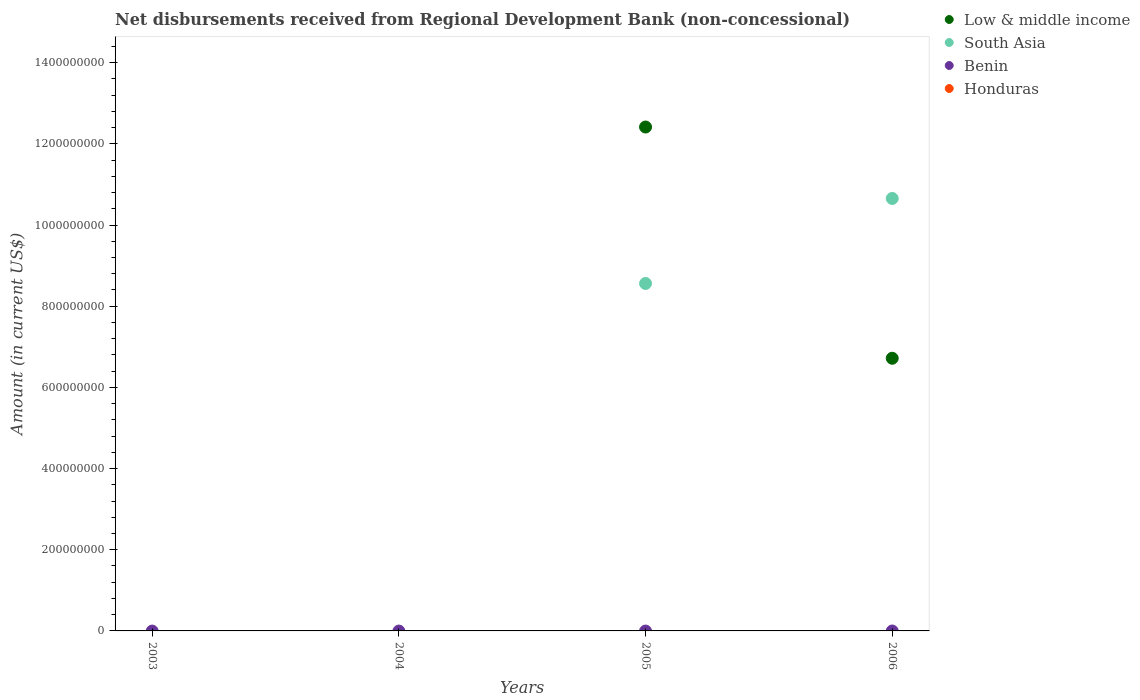What is the amount of disbursements received from Regional Development Bank in Benin in 2005?
Ensure brevity in your answer.  0. Across all years, what is the maximum amount of disbursements received from Regional Development Bank in Low & middle income?
Your answer should be compact. 1.24e+09. Across all years, what is the minimum amount of disbursements received from Regional Development Bank in Low & middle income?
Provide a succinct answer. 0. What is the total amount of disbursements received from Regional Development Bank in Benin in the graph?
Ensure brevity in your answer.  0. What is the average amount of disbursements received from Regional Development Bank in Low & middle income per year?
Ensure brevity in your answer.  4.78e+08. In the year 2006, what is the difference between the amount of disbursements received from Regional Development Bank in South Asia and amount of disbursements received from Regional Development Bank in Low & middle income?
Keep it short and to the point. 3.94e+08. What is the ratio of the amount of disbursements received from Regional Development Bank in South Asia in 2005 to that in 2006?
Your answer should be compact. 0.8. Is the difference between the amount of disbursements received from Regional Development Bank in South Asia in 2005 and 2006 greater than the difference between the amount of disbursements received from Regional Development Bank in Low & middle income in 2005 and 2006?
Your response must be concise. No. What is the difference between the highest and the lowest amount of disbursements received from Regional Development Bank in Low & middle income?
Keep it short and to the point. 1.24e+09. In how many years, is the amount of disbursements received from Regional Development Bank in South Asia greater than the average amount of disbursements received from Regional Development Bank in South Asia taken over all years?
Your answer should be very brief. 2. Is the sum of the amount of disbursements received from Regional Development Bank in Low & middle income in 2005 and 2006 greater than the maximum amount of disbursements received from Regional Development Bank in South Asia across all years?
Keep it short and to the point. Yes. How many years are there in the graph?
Offer a very short reply. 4. What is the difference between two consecutive major ticks on the Y-axis?
Your answer should be compact. 2.00e+08. Are the values on the major ticks of Y-axis written in scientific E-notation?
Your answer should be very brief. No. Does the graph contain any zero values?
Offer a terse response. Yes. Does the graph contain grids?
Your answer should be very brief. No. How are the legend labels stacked?
Give a very brief answer. Vertical. What is the title of the graph?
Your answer should be very brief. Net disbursements received from Regional Development Bank (non-concessional). Does "South Sudan" appear as one of the legend labels in the graph?
Give a very brief answer. No. What is the Amount (in current US$) of Benin in 2003?
Your answer should be compact. 0. What is the Amount (in current US$) of Honduras in 2004?
Provide a succinct answer. 0. What is the Amount (in current US$) in Low & middle income in 2005?
Your response must be concise. 1.24e+09. What is the Amount (in current US$) in South Asia in 2005?
Ensure brevity in your answer.  8.56e+08. What is the Amount (in current US$) of Benin in 2005?
Your response must be concise. 0. What is the Amount (in current US$) of Honduras in 2005?
Provide a succinct answer. 0. What is the Amount (in current US$) of Low & middle income in 2006?
Offer a very short reply. 6.72e+08. What is the Amount (in current US$) of South Asia in 2006?
Give a very brief answer. 1.07e+09. Across all years, what is the maximum Amount (in current US$) in Low & middle income?
Provide a short and direct response. 1.24e+09. Across all years, what is the maximum Amount (in current US$) in South Asia?
Provide a succinct answer. 1.07e+09. Across all years, what is the minimum Amount (in current US$) in South Asia?
Make the answer very short. 0. What is the total Amount (in current US$) in Low & middle income in the graph?
Offer a very short reply. 1.91e+09. What is the total Amount (in current US$) of South Asia in the graph?
Your response must be concise. 1.92e+09. What is the total Amount (in current US$) of Benin in the graph?
Ensure brevity in your answer.  0. What is the total Amount (in current US$) in Honduras in the graph?
Your response must be concise. 0. What is the difference between the Amount (in current US$) in Low & middle income in 2005 and that in 2006?
Offer a very short reply. 5.70e+08. What is the difference between the Amount (in current US$) of South Asia in 2005 and that in 2006?
Your answer should be compact. -2.09e+08. What is the difference between the Amount (in current US$) of Low & middle income in 2005 and the Amount (in current US$) of South Asia in 2006?
Offer a very short reply. 1.76e+08. What is the average Amount (in current US$) in Low & middle income per year?
Give a very brief answer. 4.78e+08. What is the average Amount (in current US$) in South Asia per year?
Provide a short and direct response. 4.80e+08. What is the average Amount (in current US$) in Benin per year?
Your answer should be very brief. 0. In the year 2005, what is the difference between the Amount (in current US$) in Low & middle income and Amount (in current US$) in South Asia?
Provide a short and direct response. 3.85e+08. In the year 2006, what is the difference between the Amount (in current US$) in Low & middle income and Amount (in current US$) in South Asia?
Provide a short and direct response. -3.94e+08. What is the ratio of the Amount (in current US$) in Low & middle income in 2005 to that in 2006?
Provide a short and direct response. 1.85. What is the ratio of the Amount (in current US$) in South Asia in 2005 to that in 2006?
Offer a terse response. 0.8. What is the difference between the highest and the lowest Amount (in current US$) of Low & middle income?
Give a very brief answer. 1.24e+09. What is the difference between the highest and the lowest Amount (in current US$) in South Asia?
Your response must be concise. 1.07e+09. 